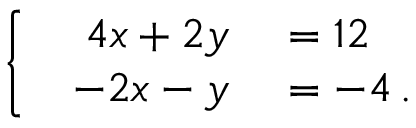<formula> <loc_0><loc_0><loc_500><loc_500>\left \{ \begin{array} { l l } { { \begin{array} { r l } { 4 x + 2 y } & = 1 2 } \\ { - 2 x - y } & = - 4 \, . } \end{array} } } \end{array}</formula> 